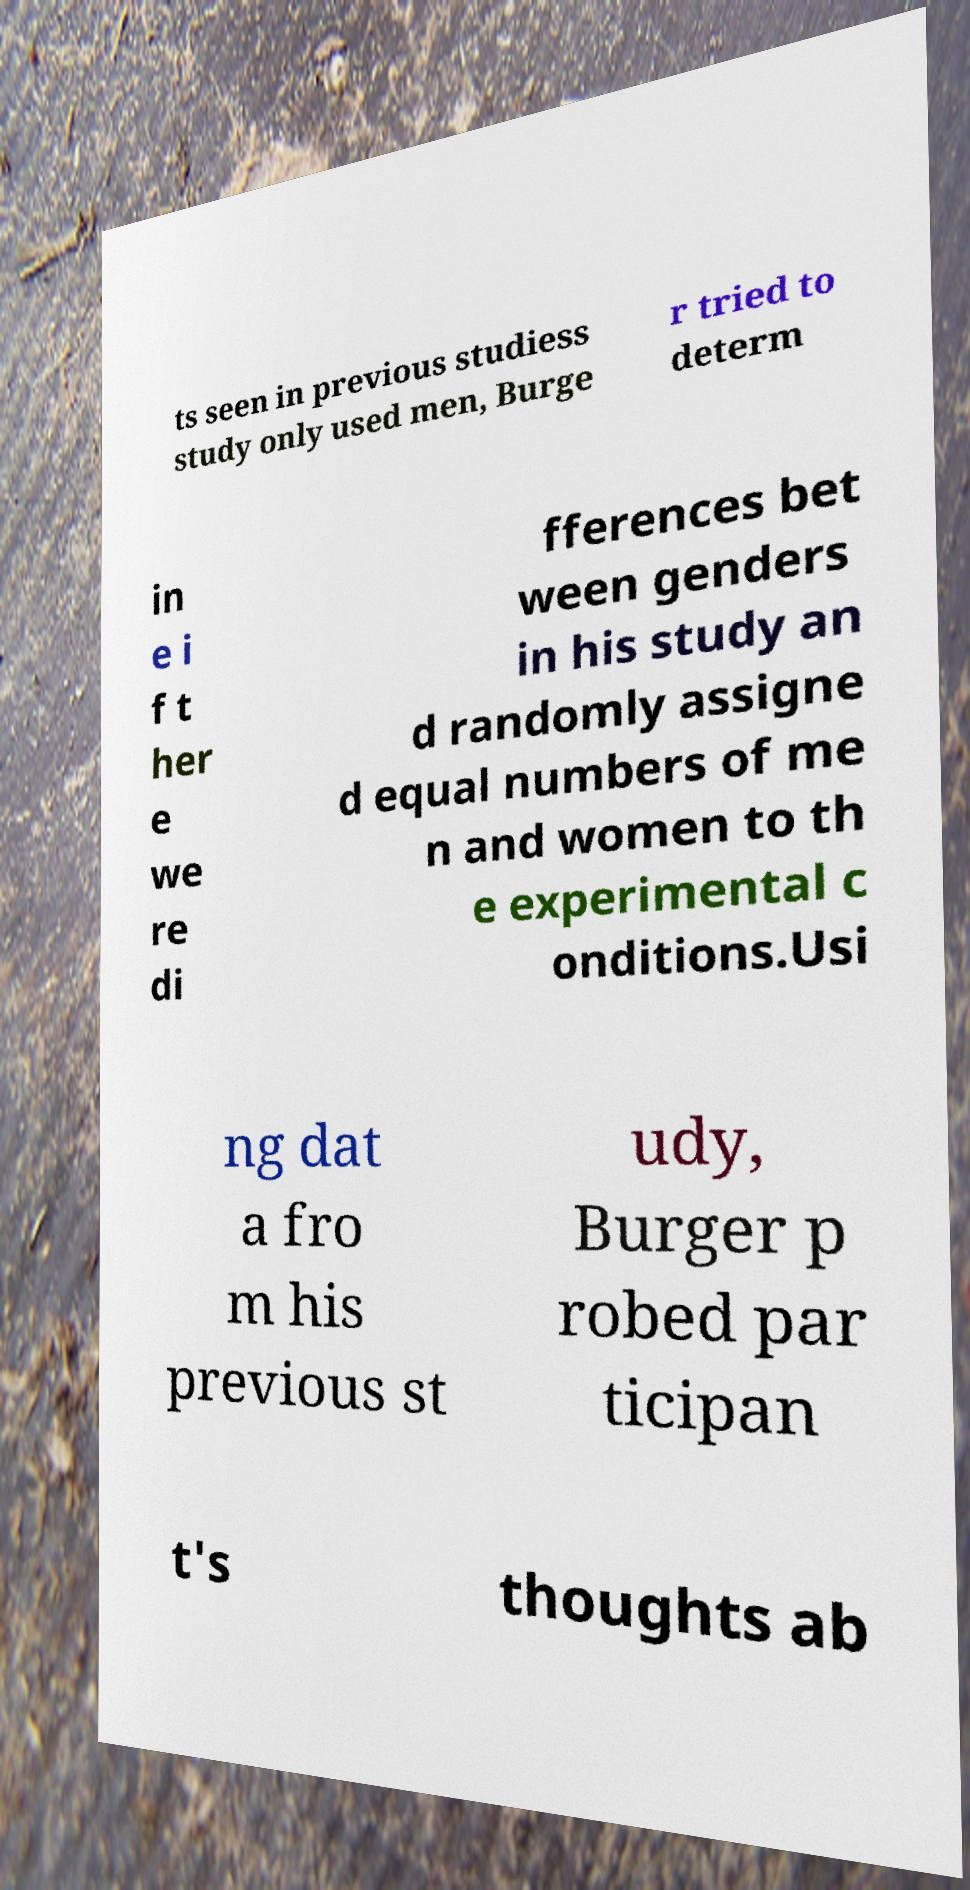Could you extract and type out the text from this image? ts seen in previous studiess study only used men, Burge r tried to determ in e i f t her e we re di fferences bet ween genders in his study an d randomly assigne d equal numbers of me n and women to th e experimental c onditions.Usi ng dat a fro m his previous st udy, Burger p robed par ticipan t's thoughts ab 